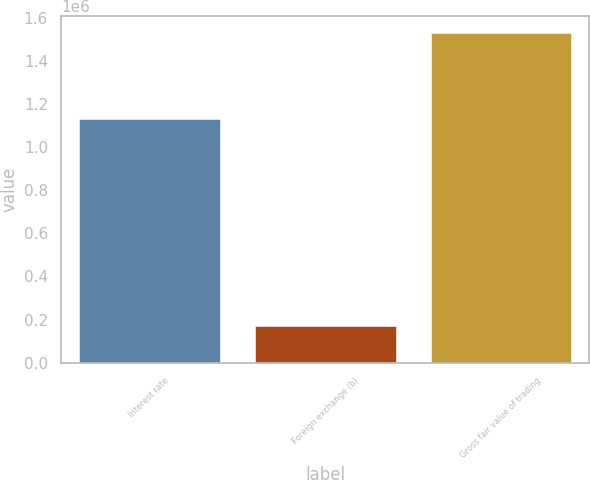<chart> <loc_0><loc_0><loc_500><loc_500><bar_chart><fcel>Interest rate<fcel>Foreign exchange (b)<fcel>Gross fair value of trading<nl><fcel>1.12798e+06<fcel>168471<fcel>1.52941e+06<nl></chart> 